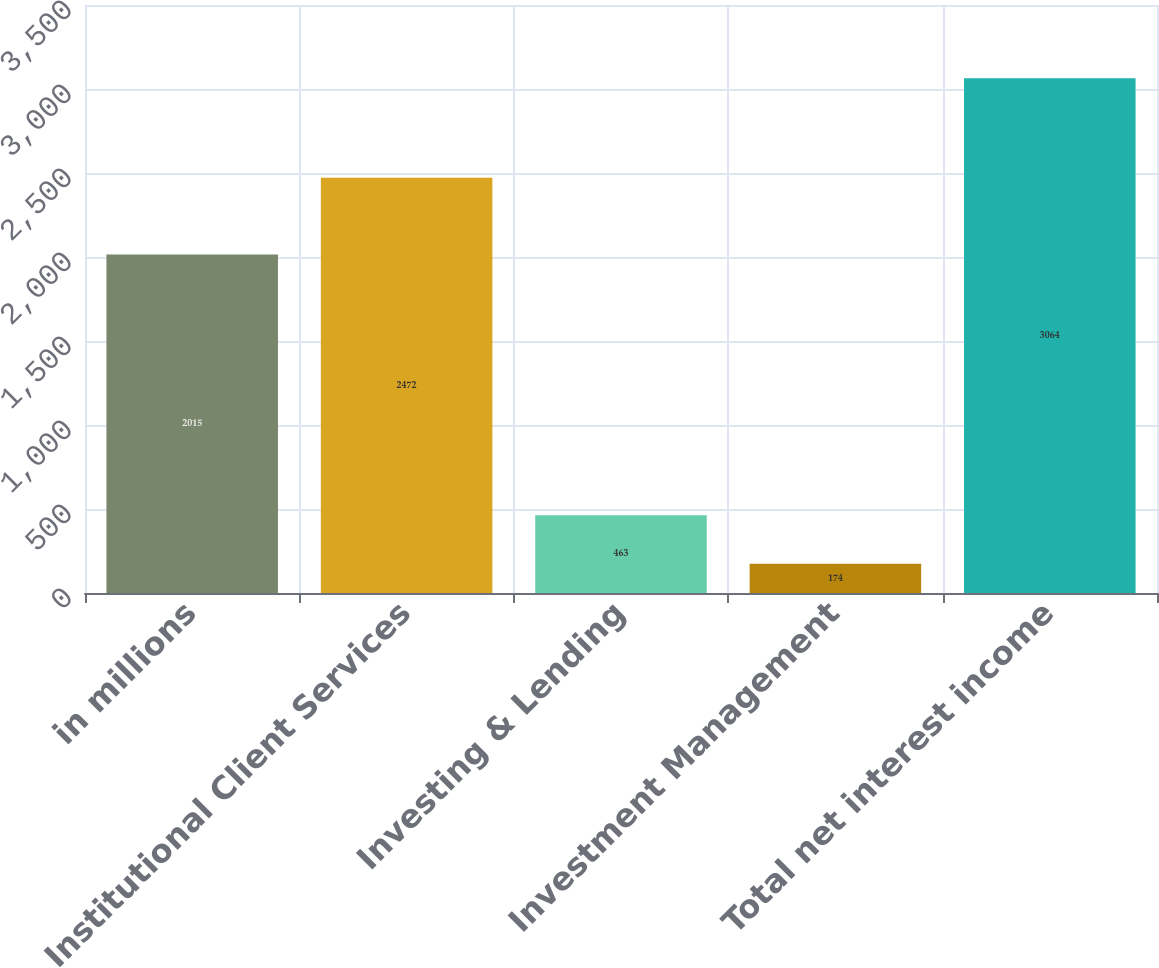Convert chart. <chart><loc_0><loc_0><loc_500><loc_500><bar_chart><fcel>in millions<fcel>Institutional Client Services<fcel>Investing & Lending<fcel>Investment Management<fcel>Total net interest income<nl><fcel>2015<fcel>2472<fcel>463<fcel>174<fcel>3064<nl></chart> 